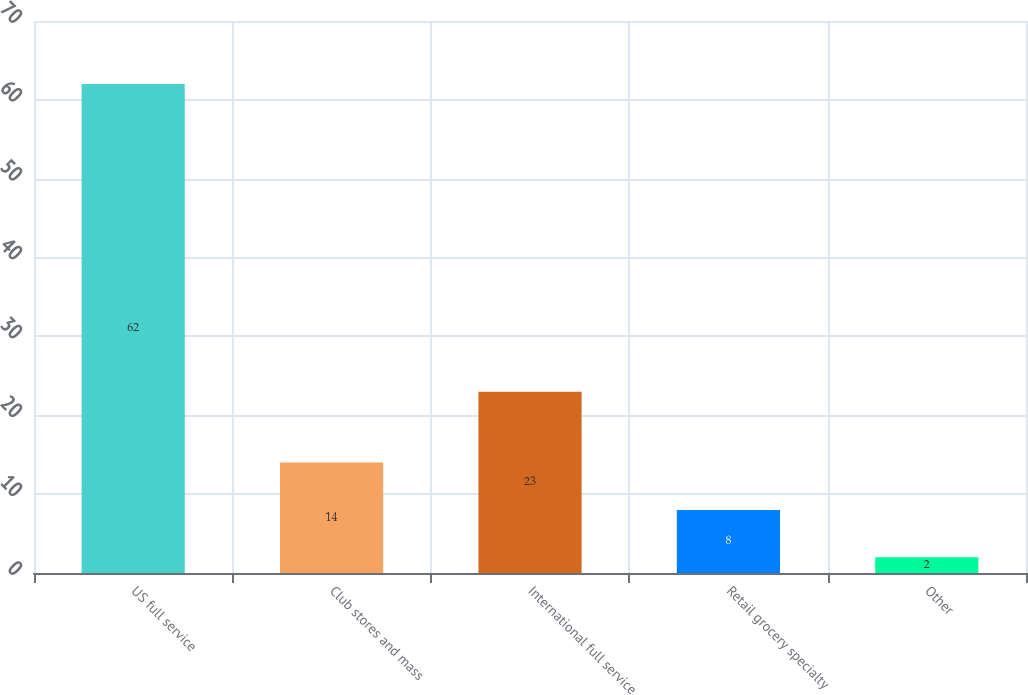Convert chart. <chart><loc_0><loc_0><loc_500><loc_500><bar_chart><fcel>US full service<fcel>Club stores and mass<fcel>International full service<fcel>Retail grocery specialty<fcel>Other<nl><fcel>62<fcel>14<fcel>23<fcel>8<fcel>2<nl></chart> 